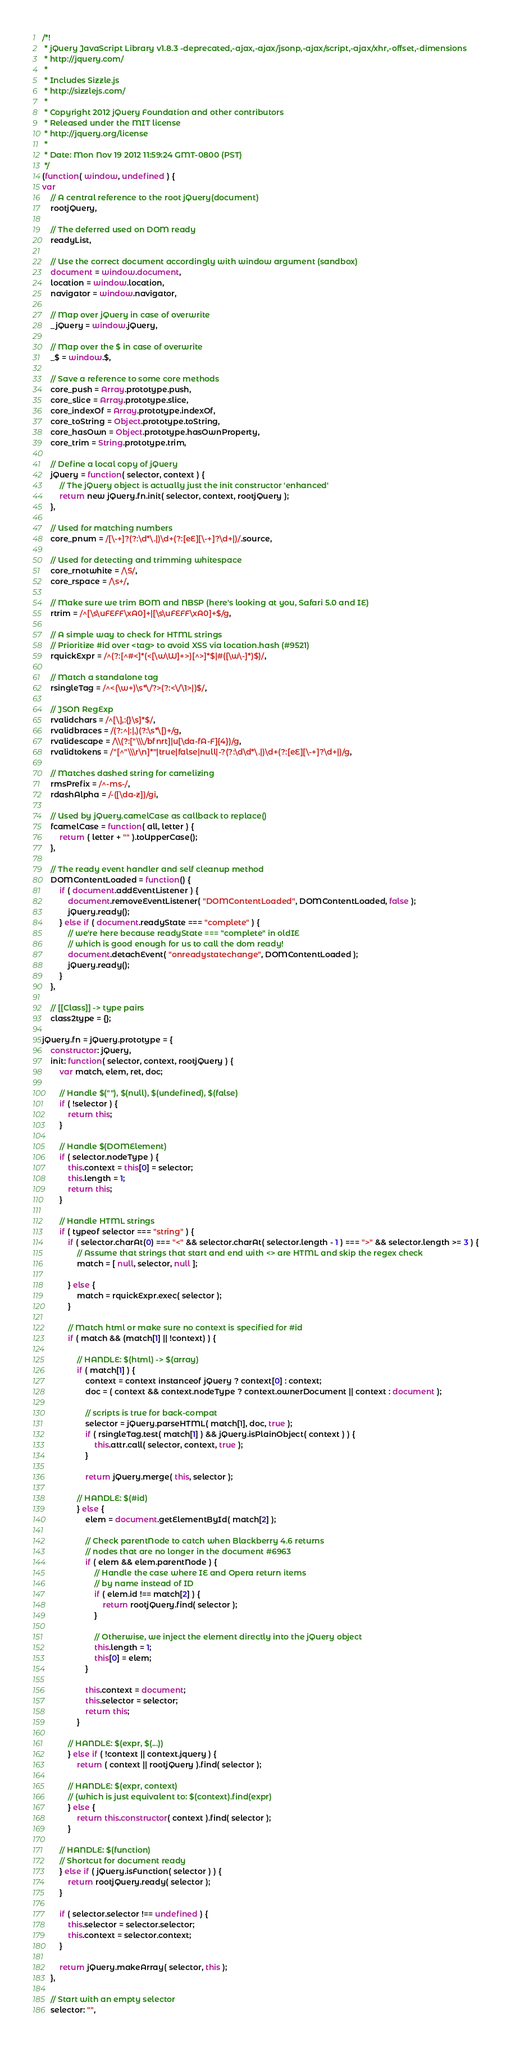Convert code to text. <code><loc_0><loc_0><loc_500><loc_500><_JavaScript_>/*!
 * jQuery JavaScript Library v1.8.3 -deprecated,-ajax,-ajax/jsonp,-ajax/script,-ajax/xhr,-offset,-dimensions
 * http://jquery.com/
 *
 * Includes Sizzle.js
 * http://sizzlejs.com/
 *
 * Copyright 2012 jQuery Foundation and other contributors
 * Released under the MIT license
 * http://jquery.org/license
 *
 * Date: Mon Nov 19 2012 11:59:24 GMT-0800 (PST)
 */
(function( window, undefined ) {
var
	// A central reference to the root jQuery(document)
	rootjQuery,

	// The deferred used on DOM ready
	readyList,

	// Use the correct document accordingly with window argument (sandbox)
	document = window.document,
	location = window.location,
	navigator = window.navigator,

	// Map over jQuery in case of overwrite
	_jQuery = window.jQuery,

	// Map over the $ in case of overwrite
	_$ = window.$,

	// Save a reference to some core methods
	core_push = Array.prototype.push,
	core_slice = Array.prototype.slice,
	core_indexOf = Array.prototype.indexOf,
	core_toString = Object.prototype.toString,
	core_hasOwn = Object.prototype.hasOwnProperty,
	core_trim = String.prototype.trim,

	// Define a local copy of jQuery
	jQuery = function( selector, context ) {
		// The jQuery object is actually just the init constructor 'enhanced'
		return new jQuery.fn.init( selector, context, rootjQuery );
	},

	// Used for matching numbers
	core_pnum = /[\-+]?(?:\d*\.|)\d+(?:[eE][\-+]?\d+|)/.source,

	// Used for detecting and trimming whitespace
	core_rnotwhite = /\S/,
	core_rspace = /\s+/,

	// Make sure we trim BOM and NBSP (here's looking at you, Safari 5.0 and IE)
	rtrim = /^[\s\uFEFF\xA0]+|[\s\uFEFF\xA0]+$/g,

	// A simple way to check for HTML strings
	// Prioritize #id over <tag> to avoid XSS via location.hash (#9521)
	rquickExpr = /^(?:[^#<]*(<[\w\W]+>)[^>]*$|#([\w\-]*)$)/,

	// Match a standalone tag
	rsingleTag = /^<(\w+)\s*\/?>(?:<\/\1>|)$/,

	// JSON RegExp
	rvalidchars = /^[\],:{}\s]*$/,
	rvalidbraces = /(?:^|:|,)(?:\s*\[)+/g,
	rvalidescape = /\\(?:["\\\/bfnrt]|u[\da-fA-F]{4})/g,
	rvalidtokens = /"[^"\\\r\n]*"|true|false|null|-?(?:\d\d*\.|)\d+(?:[eE][\-+]?\d+|)/g,

	// Matches dashed string for camelizing
	rmsPrefix = /^-ms-/,
	rdashAlpha = /-([\da-z])/gi,

	// Used by jQuery.camelCase as callback to replace()
	fcamelCase = function( all, letter ) {
		return ( letter + "" ).toUpperCase();
	},

	// The ready event handler and self cleanup method
	DOMContentLoaded = function() {
		if ( document.addEventListener ) {
			document.removeEventListener( "DOMContentLoaded", DOMContentLoaded, false );
			jQuery.ready();
		} else if ( document.readyState === "complete" ) {
			// we're here because readyState === "complete" in oldIE
			// which is good enough for us to call the dom ready!
			document.detachEvent( "onreadystatechange", DOMContentLoaded );
			jQuery.ready();
		}
	},

	// [[Class]] -> type pairs
	class2type = {};

jQuery.fn = jQuery.prototype = {
	constructor: jQuery,
	init: function( selector, context, rootjQuery ) {
		var match, elem, ret, doc;

		// Handle $(""), $(null), $(undefined), $(false)
		if ( !selector ) {
			return this;
		}

		// Handle $(DOMElement)
		if ( selector.nodeType ) {
			this.context = this[0] = selector;
			this.length = 1;
			return this;
		}

		// Handle HTML strings
		if ( typeof selector === "string" ) {
			if ( selector.charAt(0) === "<" && selector.charAt( selector.length - 1 ) === ">" && selector.length >= 3 ) {
				// Assume that strings that start and end with <> are HTML and skip the regex check
				match = [ null, selector, null ];

			} else {
				match = rquickExpr.exec( selector );
			}

			// Match html or make sure no context is specified for #id
			if ( match && (match[1] || !context) ) {

				// HANDLE: $(html) -> $(array)
				if ( match[1] ) {
					context = context instanceof jQuery ? context[0] : context;
					doc = ( context && context.nodeType ? context.ownerDocument || context : document );

					// scripts is true for back-compat
					selector = jQuery.parseHTML( match[1], doc, true );
					if ( rsingleTag.test( match[1] ) && jQuery.isPlainObject( context ) ) {
						this.attr.call( selector, context, true );
					}

					return jQuery.merge( this, selector );

				// HANDLE: $(#id)
				} else {
					elem = document.getElementById( match[2] );

					// Check parentNode to catch when Blackberry 4.6 returns
					// nodes that are no longer in the document #6963
					if ( elem && elem.parentNode ) {
						// Handle the case where IE and Opera return items
						// by name instead of ID
						if ( elem.id !== match[2] ) {
							return rootjQuery.find( selector );
						}

						// Otherwise, we inject the element directly into the jQuery object
						this.length = 1;
						this[0] = elem;
					}

					this.context = document;
					this.selector = selector;
					return this;
				}

			// HANDLE: $(expr, $(...))
			} else if ( !context || context.jquery ) {
				return ( context || rootjQuery ).find( selector );

			// HANDLE: $(expr, context)
			// (which is just equivalent to: $(context).find(expr)
			} else {
				return this.constructor( context ).find( selector );
			}

		// HANDLE: $(function)
		// Shortcut for document ready
		} else if ( jQuery.isFunction( selector ) ) {
			return rootjQuery.ready( selector );
		}

		if ( selector.selector !== undefined ) {
			this.selector = selector.selector;
			this.context = selector.context;
		}

		return jQuery.makeArray( selector, this );
	},

	// Start with an empty selector
	selector: "",
</code> 